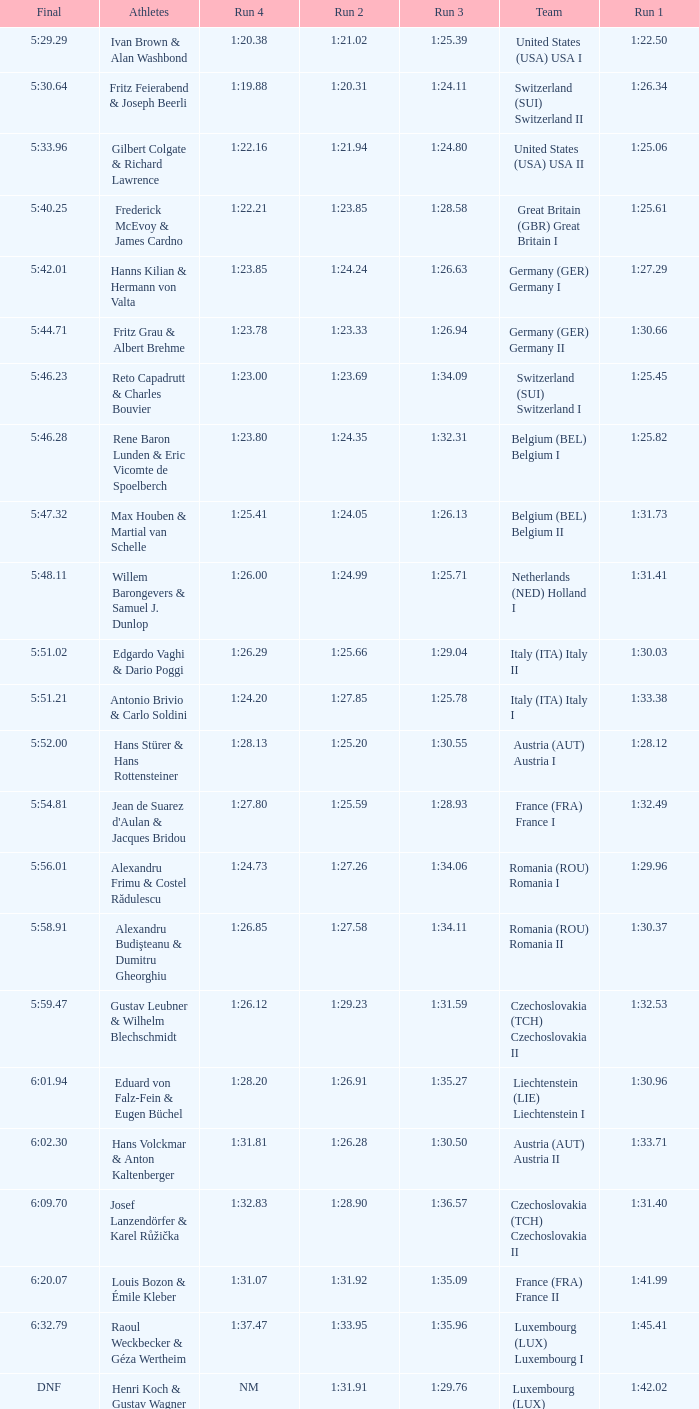Which Run 4 has a Run 1 of 1:25.82? 1:23.80. 